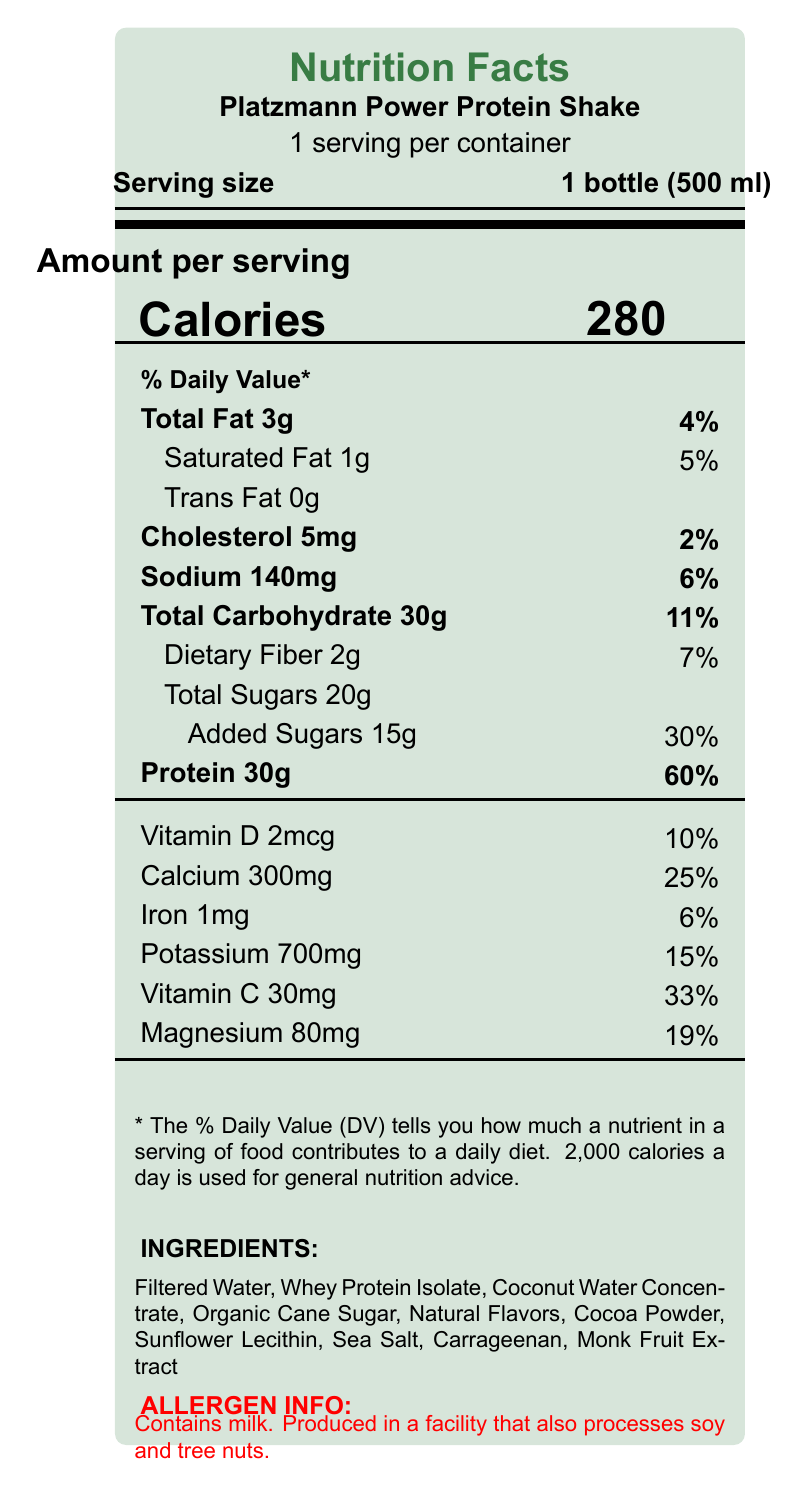what is the serving size mentioned on the label? The serving size is clearly indicated on the label as "1 bottle (500 ml)".
Answer: 1 bottle (500 ml) How many calories are there per serving? The label lists the calorie count per serving as 280.
Answer: 280 What percentage of the daily value of protein is in one serving? The label states that one serving contains 60% of the daily value of protein.
Answer: 60% What are the total carbohydrates in one serving? The label specifies that there are 30g of total carbohydrates per serving.
Answer: 30g Does the product contain any trans fat? According to the nutrition label, the product contains 0g of trans fat.
Answer: No How much sodium does one serving provide? The nutrition label indicates that one serving contains 140mg of sodium.
Answer: 140mg Which ingredient is listed first in the ingredients section? The first ingredient listed on the label is Filtered Water.
Answer: Filtered Water What is the daily value percentage of added sugars? The label states that added sugars make up 30% of the daily value.
Answer: 30% What is the amount of dietary fiber per serving? The nutrition label indicates that there are 2g of dietary fiber per serving.
Answer: 2g Which mineral provides 25% of the daily value in each serving? A. Calcium B. Iron C. Potassium According to the label, calcium provides 25% of the daily value in each serving.
Answer: A What is the official recovery drink of the Platzmann-Sauerland Open? A. Platzmann Energy Drink B. Platzmann Power Protein Shake C. Platzmann Hydration Mix The label mentions that the Platzmann Power Protein Shake is the official recovery drink of the Platzmann-Sauerland Open.
Answer: B Is the product manufactured in Germany? The label states that the product is manufactured by Sauerland Sports Nutrition GmbH, Arnsberg, Germany.
Answer: Yes Does the product contain nuts? The label indicates that the product is produced in a facility that processes tree nuts, but it does not specify if the product itself contains nuts.
Answer: Cannot be determined Summarize the key information provided on the Platzmann Power Protein Shake label. The summary is a detailed synthesis of all the key details provided in the document including nutritional facts, ingredient list, allergen info, and brand claims.
Answer: The Platzmann Power Protein Shake is a recovery drink designed for post-match muscle repair, containing 280 calories per 500 ml bottle. It provides 60% of the daily value of protein along with various vitamins and minerals such as calcium, vitamin C, and magnesium. The ingredients include filtered water, whey protein isolate, and organic cane sugar. The product contains milk and is processed in a facility that also processes soy and tree nuts. It is the official recovery drink of the Platzmann-Sauerland Open and is manufactured in Germany by Sauerland Sports Nutrition GmbH. 